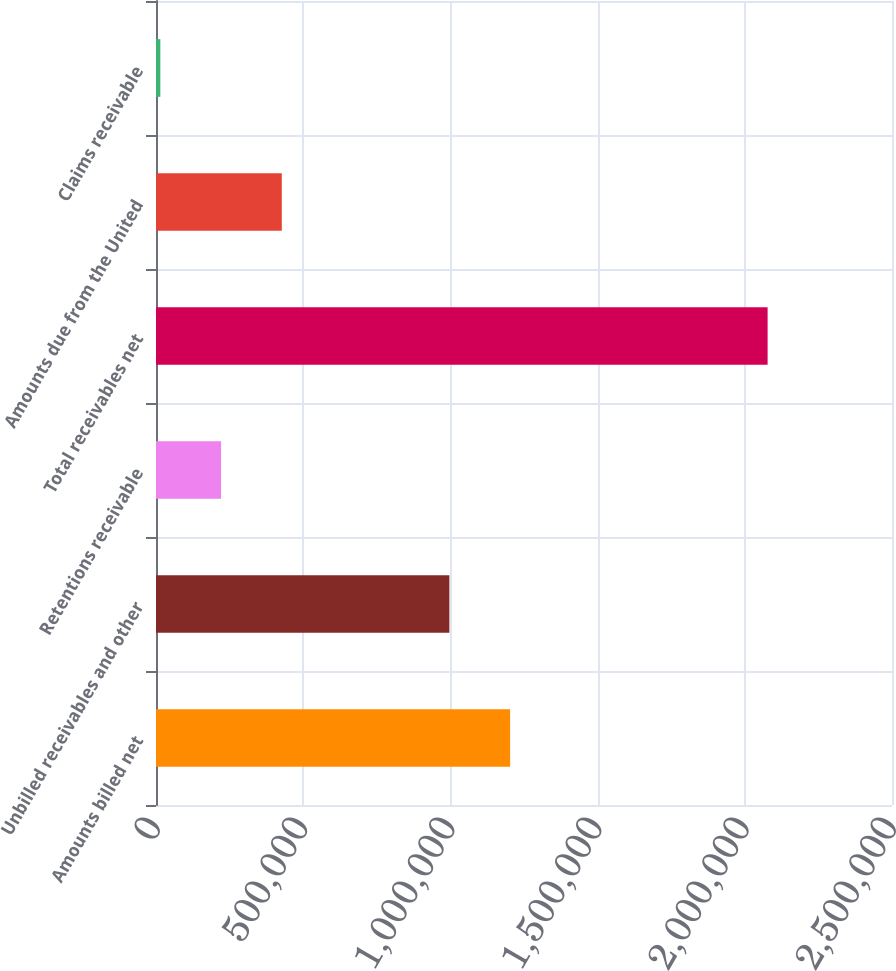Convert chart. <chart><loc_0><loc_0><loc_500><loc_500><bar_chart><fcel>Amounts billed net<fcel>Unbilled receivables and other<fcel>Retentions receivable<fcel>Total receivables net<fcel>Amounts due from the United<fcel>Claims receivable<nl><fcel>1.20279e+06<fcel>996516<fcel>220990<fcel>2.07749e+06<fcel>427268<fcel>14712<nl></chart> 